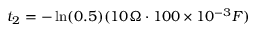Convert formula to latex. <formula><loc_0><loc_0><loc_500><loc_500>t _ { 2 } = - \ln ( 0 . 5 ) ( 1 0 \Omega \cdot 1 0 0 \times 1 0 ^ { - 3 } F )</formula> 